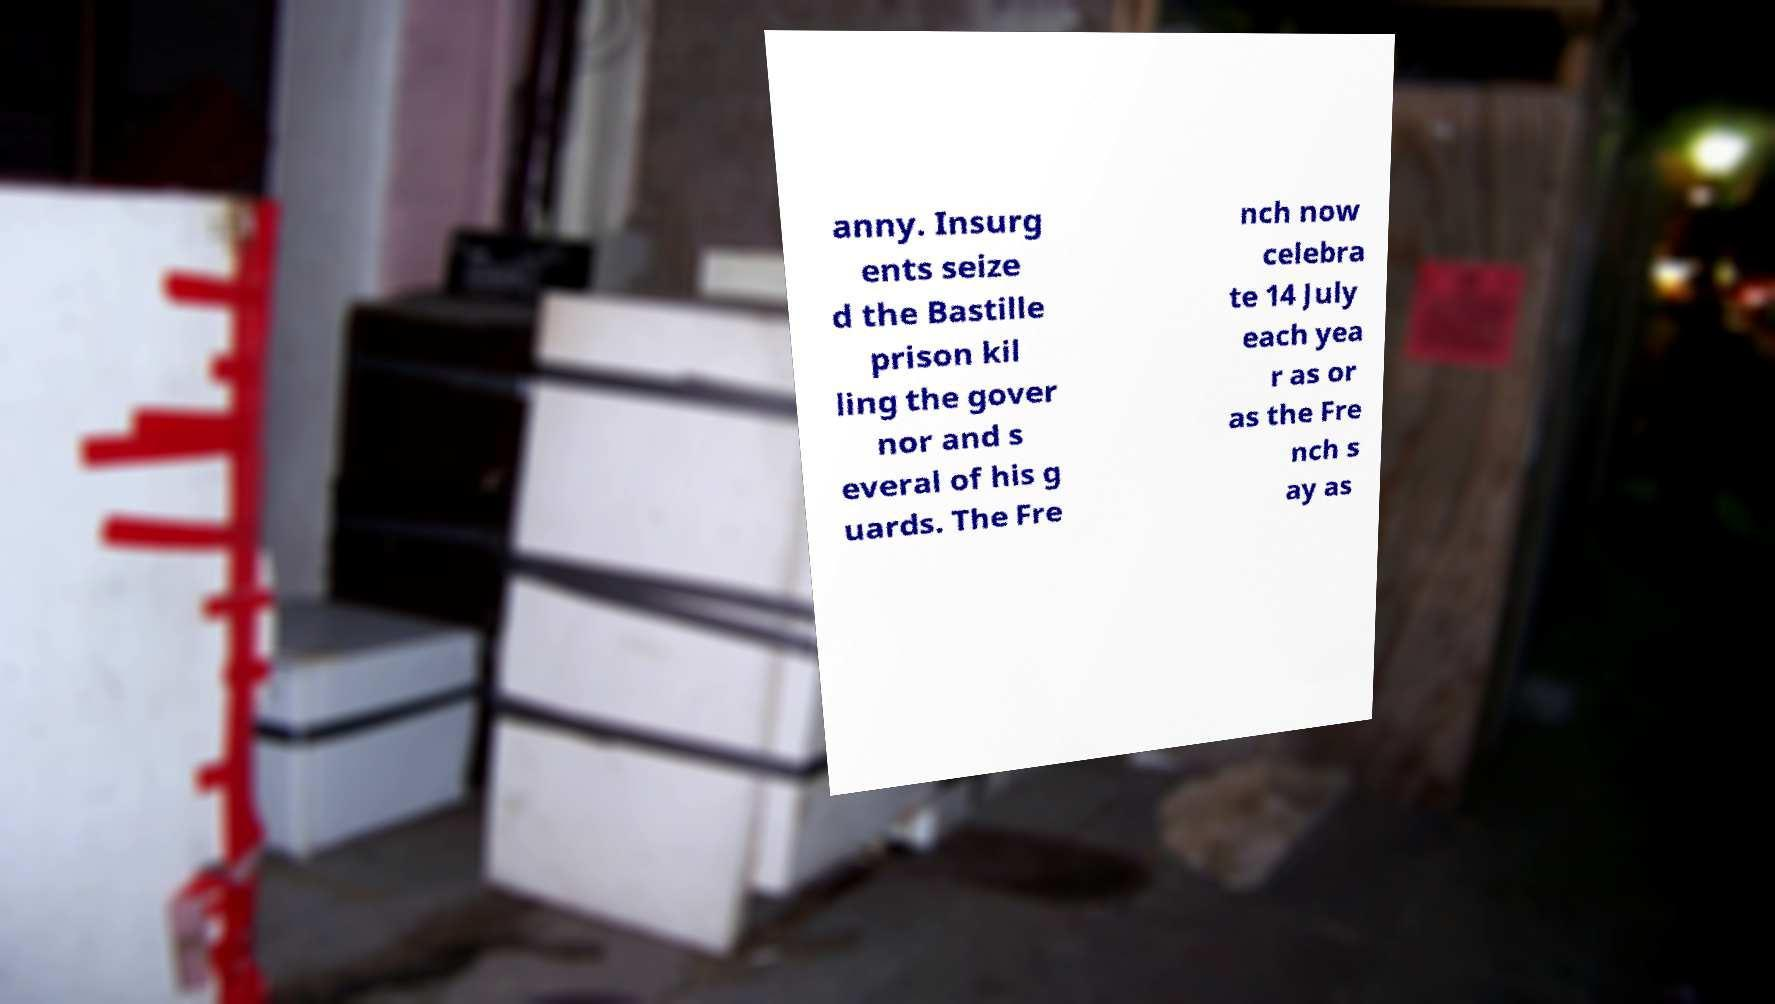Please read and relay the text visible in this image. What does it say? anny. Insurg ents seize d the Bastille prison kil ling the gover nor and s everal of his g uards. The Fre nch now celebra te 14 July each yea r as or as the Fre nch s ay as 